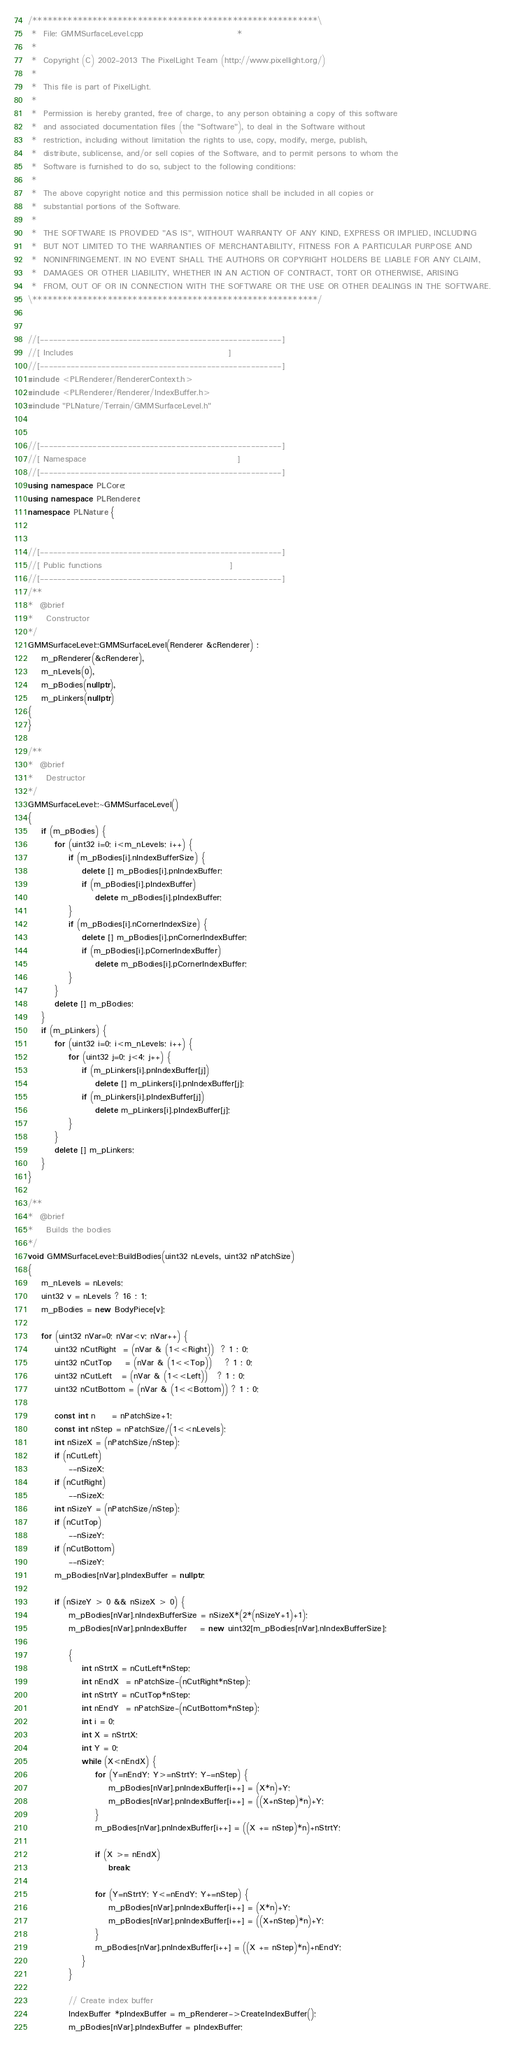Convert code to text. <code><loc_0><loc_0><loc_500><loc_500><_C++_>/*********************************************************\
 *  File: GMMSurfaceLevel.cpp                            *
 *
 *  Copyright (C) 2002-2013 The PixelLight Team (http://www.pixellight.org/)
 *
 *  This file is part of PixelLight.
 *
 *  Permission is hereby granted, free of charge, to any person obtaining a copy of this software
 *  and associated documentation files (the "Software"), to deal in the Software without
 *  restriction, including without limitation the rights to use, copy, modify, merge, publish,
 *  distribute, sublicense, and/or sell copies of the Software, and to permit persons to whom the
 *  Software is furnished to do so, subject to the following conditions:
 *
 *  The above copyright notice and this permission notice shall be included in all copies or
 *  substantial portions of the Software.
 *
 *  THE SOFTWARE IS PROVIDED "AS IS", WITHOUT WARRANTY OF ANY KIND, EXPRESS OR IMPLIED, INCLUDING
 *  BUT NOT LIMITED TO THE WARRANTIES OF MERCHANTABILITY, FITNESS FOR A PARTICULAR PURPOSE AND
 *  NONINFRINGEMENT. IN NO EVENT SHALL THE AUTHORS OR COPYRIGHT HOLDERS BE LIABLE FOR ANY CLAIM,
 *  DAMAGES OR OTHER LIABILITY, WHETHER IN AN ACTION OF CONTRACT, TORT OR OTHERWISE, ARISING
 *  FROM, OUT OF OR IN CONNECTION WITH THE SOFTWARE OR THE USE OR OTHER DEALINGS IN THE SOFTWARE.
\*********************************************************/


//[-------------------------------------------------------]
//[ Includes                                              ]
//[-------------------------------------------------------]
#include <PLRenderer/RendererContext.h>
#include <PLRenderer/Renderer/IndexBuffer.h>
#include "PLNature/Terrain/GMMSurfaceLevel.h"


//[-------------------------------------------------------]
//[ Namespace                                             ]
//[-------------------------------------------------------]
using namespace PLCore;
using namespace PLRenderer;
namespace PLNature {


//[-------------------------------------------------------]
//[ Public functions                                      ]
//[-------------------------------------------------------]
/**
*  @brief
*    Constructor
*/
GMMSurfaceLevel::GMMSurfaceLevel(Renderer &cRenderer) :
	m_pRenderer(&cRenderer),
	m_nLevels(0),
	m_pBodies(nullptr),
	m_pLinkers(nullptr)
{
}

/**
*  @brief
*    Destructor
*/
GMMSurfaceLevel::~GMMSurfaceLevel()
{
	if (m_pBodies) {
		for (uint32 i=0; i<m_nLevels; i++) {
			if (m_pBodies[i].nIndexBufferSize) {
				delete [] m_pBodies[i].pnIndexBuffer;
				if (m_pBodies[i].pIndexBuffer)
					delete m_pBodies[i].pIndexBuffer;
			}
			if (m_pBodies[i].nCornerIndexSize) {
				delete [] m_pBodies[i].pnCornerIndexBuffer;
				if (m_pBodies[i].pCornerIndexBuffer)
					delete m_pBodies[i].pCornerIndexBuffer;
			}
		}
		delete [] m_pBodies;
	}
	if (m_pLinkers) {
		for (uint32 i=0; i<m_nLevels; i++) {
			for (uint32 j=0; j<4; j++) {
				if (m_pLinkers[i].pnIndexBuffer[j])
					delete [] m_pLinkers[i].pnIndexBuffer[j];
				if (m_pLinkers[i].pIndexBuffer[j])
					delete m_pLinkers[i].pIndexBuffer[j];
			}
		}
		delete [] m_pLinkers;
	}
}

/**
*  @brief
*    Builds the bodies
*/
void GMMSurfaceLevel::BuildBodies(uint32 nLevels, uint32 nPatchSize)
{
	m_nLevels = nLevels;
	uint32 v = nLevels ? 16 : 1;
	m_pBodies = new BodyPiece[v];

	for (uint32 nVar=0; nVar<v; nVar++) {
		uint32 nCutRight  = (nVar & (1<<Right))  ? 1 : 0;
		uint32 nCutTop    = (nVar & (1<<Top))    ? 1 : 0;
		uint32 nCutLeft   = (nVar & (1<<Left))   ? 1 : 0;
		uint32 nCutBottom = (nVar & (1<<Bottom)) ? 1 : 0;

		const int n     = nPatchSize+1;
		const int nStep = nPatchSize/(1<<nLevels);
		int nSizeX = (nPatchSize/nStep);
		if (nCutLeft)
			--nSizeX;
		if (nCutRight)
			--nSizeX;
		int nSizeY = (nPatchSize/nStep);
		if (nCutTop)
			--nSizeY;
		if (nCutBottom)
			--nSizeY;
		m_pBodies[nVar].pIndexBuffer = nullptr;

		if (nSizeY > 0 && nSizeX > 0) {
			m_pBodies[nVar].nIndexBufferSize = nSizeX*(2*(nSizeY+1)+1);
			m_pBodies[nVar].pnIndexBuffer    = new uint32[m_pBodies[nVar].nIndexBufferSize];

			{
				int nStrtX = nCutLeft*nStep;
				int nEndX  = nPatchSize-(nCutRight*nStep);
				int nStrtY = nCutTop*nStep;
				int nEndY  = nPatchSize-(nCutBottom*nStep);
				int i = 0;
				int X = nStrtX;
				int Y = 0;
				while (X<nEndX) {
					for (Y=nEndY; Y>=nStrtY; Y-=nStep) {
						m_pBodies[nVar].pnIndexBuffer[i++] = (X*n)+Y;
						m_pBodies[nVar].pnIndexBuffer[i++] = ((X+nStep)*n)+Y;
					}
					m_pBodies[nVar].pnIndexBuffer[i++] = ((X += nStep)*n)+nStrtY;

					if (X >= nEndX)
						break;

					for (Y=nStrtY; Y<=nEndY; Y+=nStep) {
						m_pBodies[nVar].pnIndexBuffer[i++] = (X*n)+Y;
						m_pBodies[nVar].pnIndexBuffer[i++] = ((X+nStep)*n)+Y;
					}
					m_pBodies[nVar].pnIndexBuffer[i++] = ((X += nStep)*n)+nEndY;
				}
			}

			// Create index buffer
			IndexBuffer *pIndexBuffer = m_pRenderer->CreateIndexBuffer();
			m_pBodies[nVar].pIndexBuffer = pIndexBuffer;</code> 